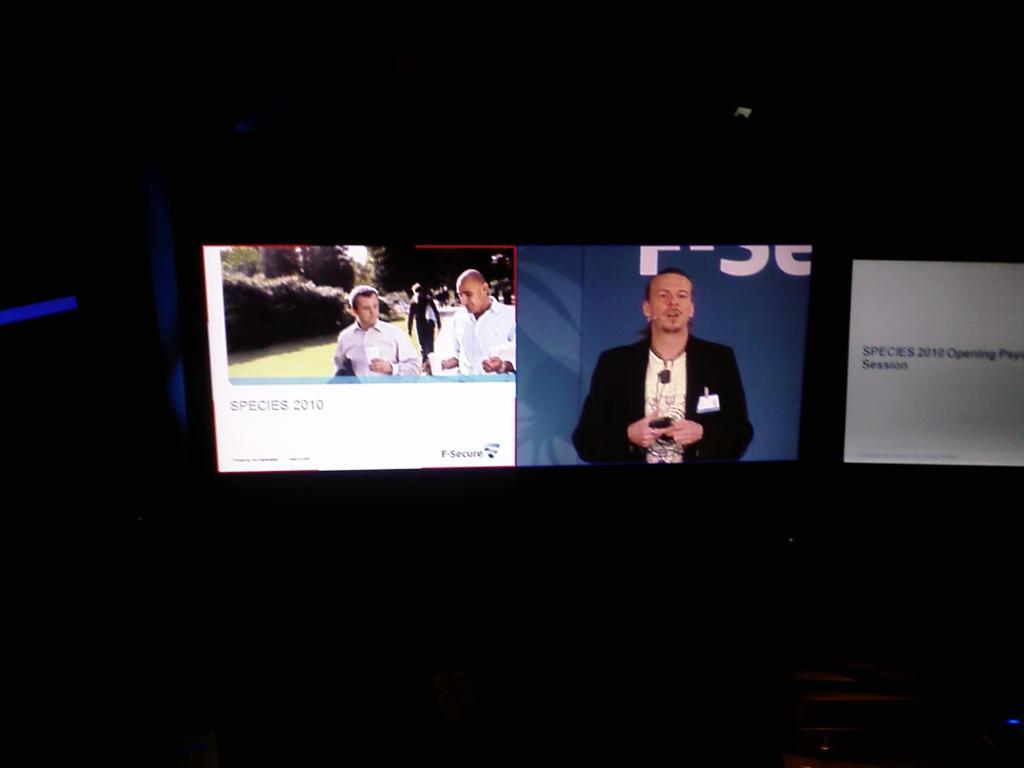Is this a television season?
Your answer should be very brief. Unanswerable. 